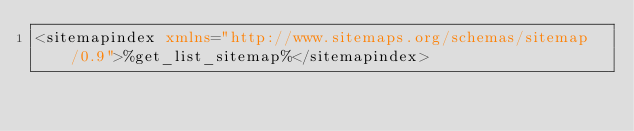Convert code to text. <code><loc_0><loc_0><loc_500><loc_500><_XML_><sitemapindex xmlns="http://www.sitemaps.org/schemas/sitemap/0.9">%get_list_sitemap%</sitemapindex>
</code> 